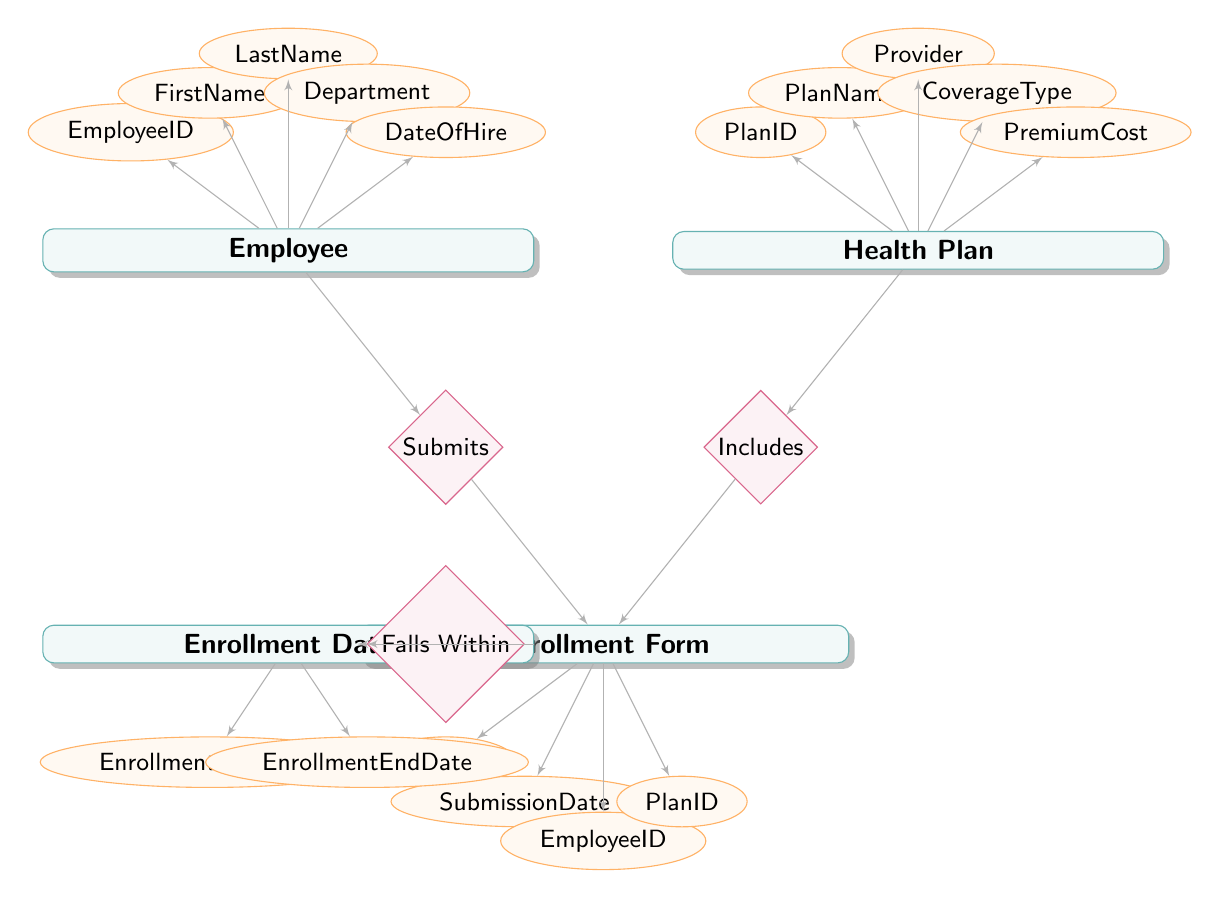What entities are present in the diagram? The diagram includes four entities which comprise "Employee," "Health Plan," "Enrollment Form," and "Enrollment Date." Each of these entities is visually represented with a rectangle and labeled accordingly.
Answer: Employee, Health Plan, Enrollment Form, Enrollment Date How many attributes does the Employee entity have? The Employee entity has five attributes: EmployeeID, FirstName, LastName, Department, and DateOfHire. These attributes are shown as ellipses connected to the Employee rectangle.
Answer: 5 What is the relationship type between Employee and Enrollment Form? The relationship type between Employee and Enrollment Form is labeled "Submits," which indicates that employees are responsible for submitting enrollment forms as per the diagram.
Answer: Submits Which entity includes the attribute PlanID? The attribute PlanID is included in the Health Plan entity, as indicated by the connection from the Health Plan rectangle to the attribute ellipse for PlanID.
Answer: Health Plan What types of relationships are shown in the diagram? The diagram shows three types of relationships: "Submits," "Includes," and "Falls Within." These relationships connect the entities to illustrate how they interrelate in the enrollment process.
Answer: Submits, Includes, Falls Within Which form relates an employee to a health plan? The Enrollment Form is what relates an employee to a health plan. This is demonstrated by the connection of the Enrollment Form with both the Employee and Health Plan entities, indicating the form's role in bridging their relationship.
Answer: Enrollment Form What are the attributes associated with Enrollment Form? The Enrollment Form entity has four attributes: FormID, SubmissionDate, EmployeeID, and PlanID. These are necessary for keeping track of submissions tied to employees and health plans.
Answer: FormID, SubmissionDate, EmployeeID, PlanID Which entity has coverage types as an attribute? The Health Plan entity has CoverageType as one of its attributes. This attribute describes the type of coverage offered by each health plan in the diagram.
Answer: Health Plan What does the Enrollment Date entity represent in the context of enrollment? The Enrollment Date entity serves to represent the timeframe for enrollment, specifically defining when the enrollment begins and ends, allowing for a clear understanding of the enrollment period.
Answer: Enrollment Date 